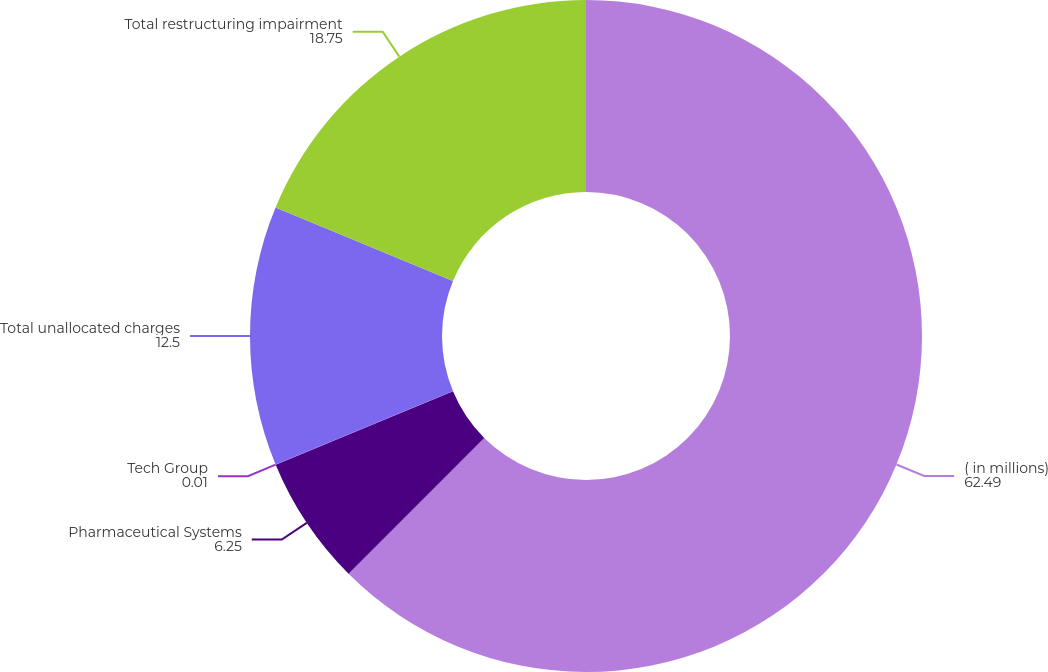Convert chart to OTSL. <chart><loc_0><loc_0><loc_500><loc_500><pie_chart><fcel>( in millions)<fcel>Pharmaceutical Systems<fcel>Tech Group<fcel>Total unallocated charges<fcel>Total restructuring impairment<nl><fcel>62.49%<fcel>6.25%<fcel>0.01%<fcel>12.5%<fcel>18.75%<nl></chart> 